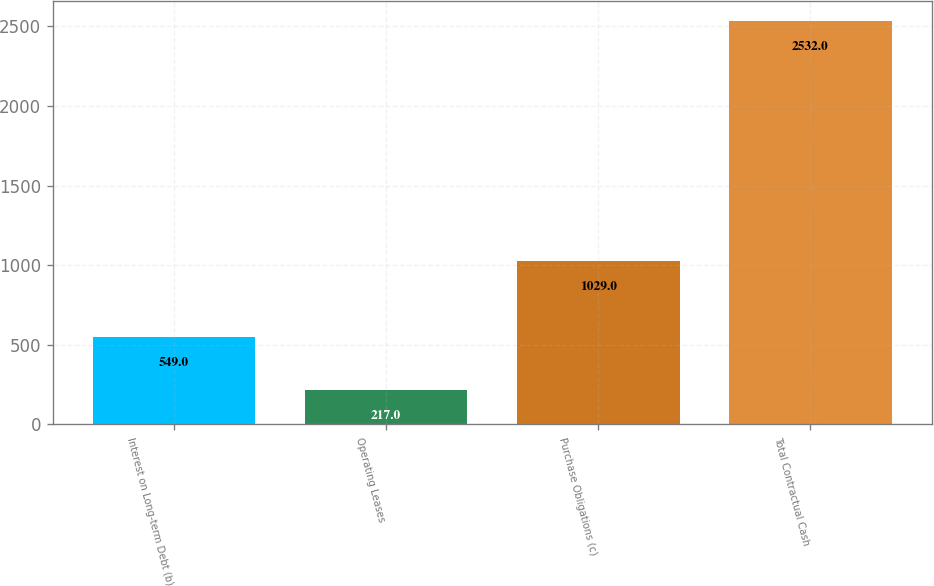<chart> <loc_0><loc_0><loc_500><loc_500><bar_chart><fcel>Interest on Long-term Debt (b)<fcel>Operating Leases<fcel>Purchase Obligations (c)<fcel>Total Contractual Cash<nl><fcel>549<fcel>217<fcel>1029<fcel>2532<nl></chart> 